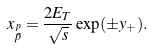<formula> <loc_0><loc_0><loc_500><loc_500>x _ { \stackrel { p } { \bar { p } } } = \frac { 2 E _ { T } } { \sqrt { s } } \exp ( \pm y _ { + } ) .</formula> 